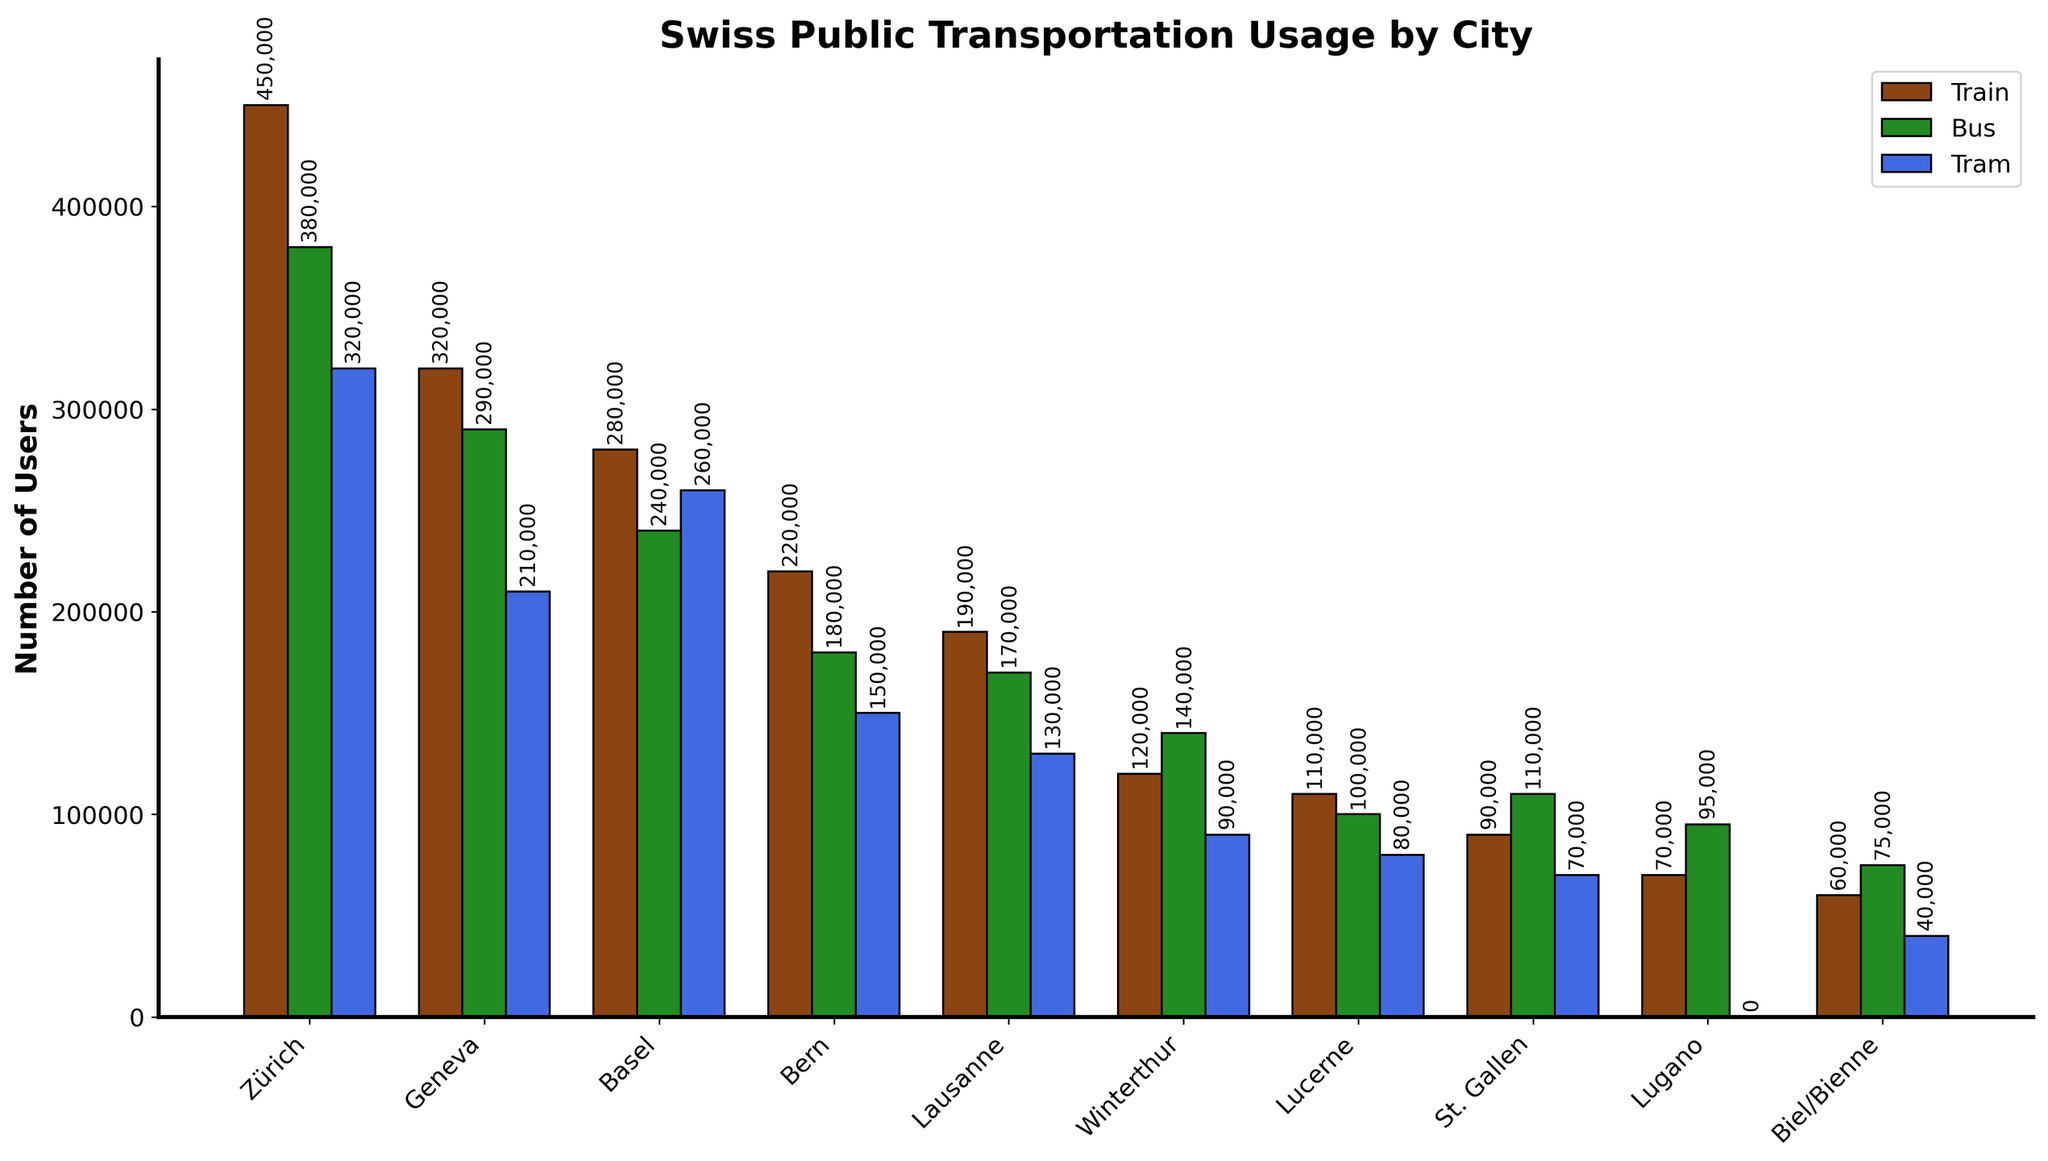Which city has the highest usage of trains? Compare the heights of the bars representing train usage across all the cities. Zürich has the tallest bar.
Answer: Zürich Which mode of transportation is most used in Geneva? Compare the heights of the bars for train, bus, and tram in Geneva. The train bar is the tallest.
Answer: Train How much greater is the bus usage in Lugano compared to the tram usage in Lugano? Subtract the height of the tram bar from the height of the bus bar in Lugano. Since the tram usage is 0, the difference is the bus usage in Lugano.
Answer: 95,000 Which city has the least usage of trams? Compare the heights of the tram bars across all the cities. Lugano's tram bar is non-existent (0).
Answer: Lugano Which city uses buses more than trams but less than trains? Identify the cities where the bus usage bar is taller than the tram bar but shorter than the train bar. Zürich and Geneva fit this criteria; Zürich is one example.
Answer: Zürich What's the total public transportation usage (train, bus, and tram combined) in Lausanne? Sum the heights of the bars for train, bus, and tram in Lausanne (190,000 + 170,000 + 130,000).
Answer: 490,000 In which city is the difference between train and bus usage the smallest? Calculate the absolute differences between the train and bus usage bars for each city and find the smallest difference. St. Gallen has the smallest difference (90,000 - 110,000 = 20,000).
Answer: St. Gallen Which city has the second-highest tram usage? Compare the heights of the tram usage bars across all cities and identify the second-tallest. Basel has the second-highest tram usage bar.
Answer: Basel If Zürich and Geneva's train usages were combined, what would be the total? Sum the heights of the train usage bars for Zürich and Geneva (450,000 + 320,000).
Answer: 770,000 Is bus usage in Bern more than in Lucerne? Compare the heights of the bus usage bars for Bern and Lucerne. The bus usage bar in Bern is taller.
Answer: Yes 